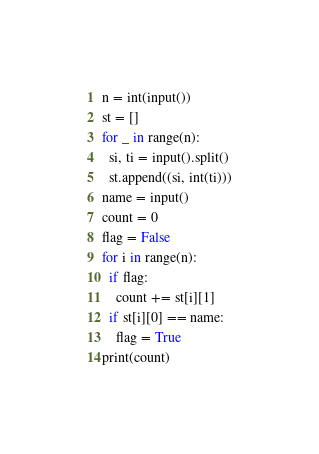<code> <loc_0><loc_0><loc_500><loc_500><_Python_>n = int(input())
st = []
for _ in range(n):
  si, ti = input().split()
  st.append((si, int(ti)))
name = input()
count = 0
flag = False
for i in range(n):
  if flag:
    count += st[i][1]
  if st[i][0] == name:
    flag = True
print(count)</code> 